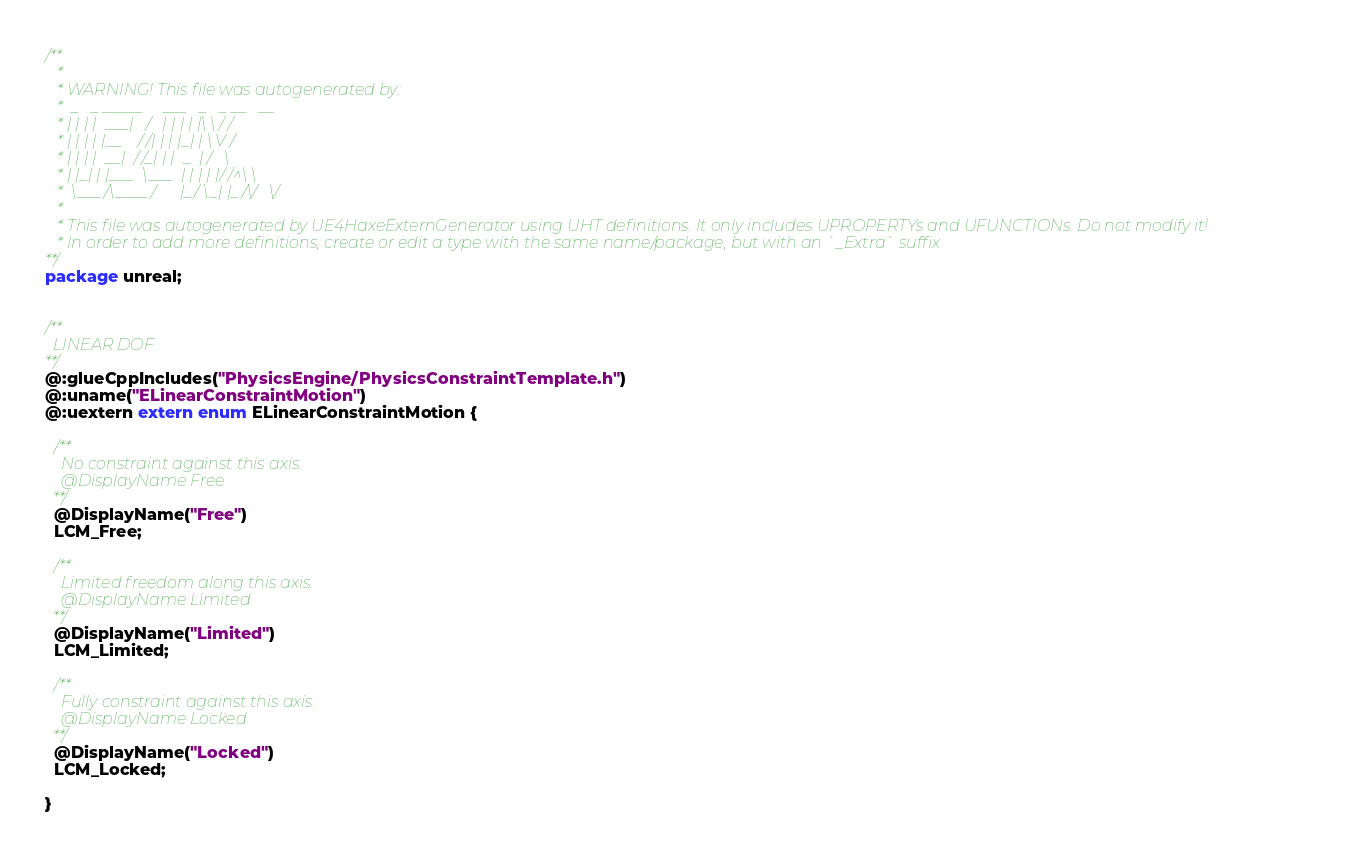Convert code to text. <code><loc_0><loc_0><loc_500><loc_500><_Haxe_>/**
   * 
   * WARNING! This file was autogenerated by: 
   *  _   _ _____     ___   _   _ __   __ 
   * | | | |  ___|   /   | | | | |\ \ / / 
   * | | | | |__    / /| | | |_| | \ V /  
   * | | | |  __|  / /_| | |  _  | /   \  
   * | |_| | |___  \___  | | | | |/ /^\ \ 
   *  \___/\____/      |_/ \_| |_/\/   \/ 
   * 
   * This file was autogenerated by UE4HaxeExternGenerator using UHT definitions. It only includes UPROPERTYs and UFUNCTIONs. Do not modify it!
   * In order to add more definitions, create or edit a type with the same name/package, but with an `_Extra` suffix
**/
package unreal;


/**
  LINEAR DOF
**/
@:glueCppIncludes("PhysicsEngine/PhysicsConstraintTemplate.h")
@:uname("ELinearConstraintMotion")
@:uextern extern enum ELinearConstraintMotion {
  
  /**
    No constraint against this axis.
    @DisplayName Free
  **/
  @DisplayName("Free")
  LCM_Free;
  
  /**
    Limited freedom along this axis.
    @DisplayName Limited
  **/
  @DisplayName("Limited")
  LCM_Limited;
  
  /**
    Fully constraint against this axis.
    @DisplayName Locked
  **/
  @DisplayName("Locked")
  LCM_Locked;
  
}
</code> 